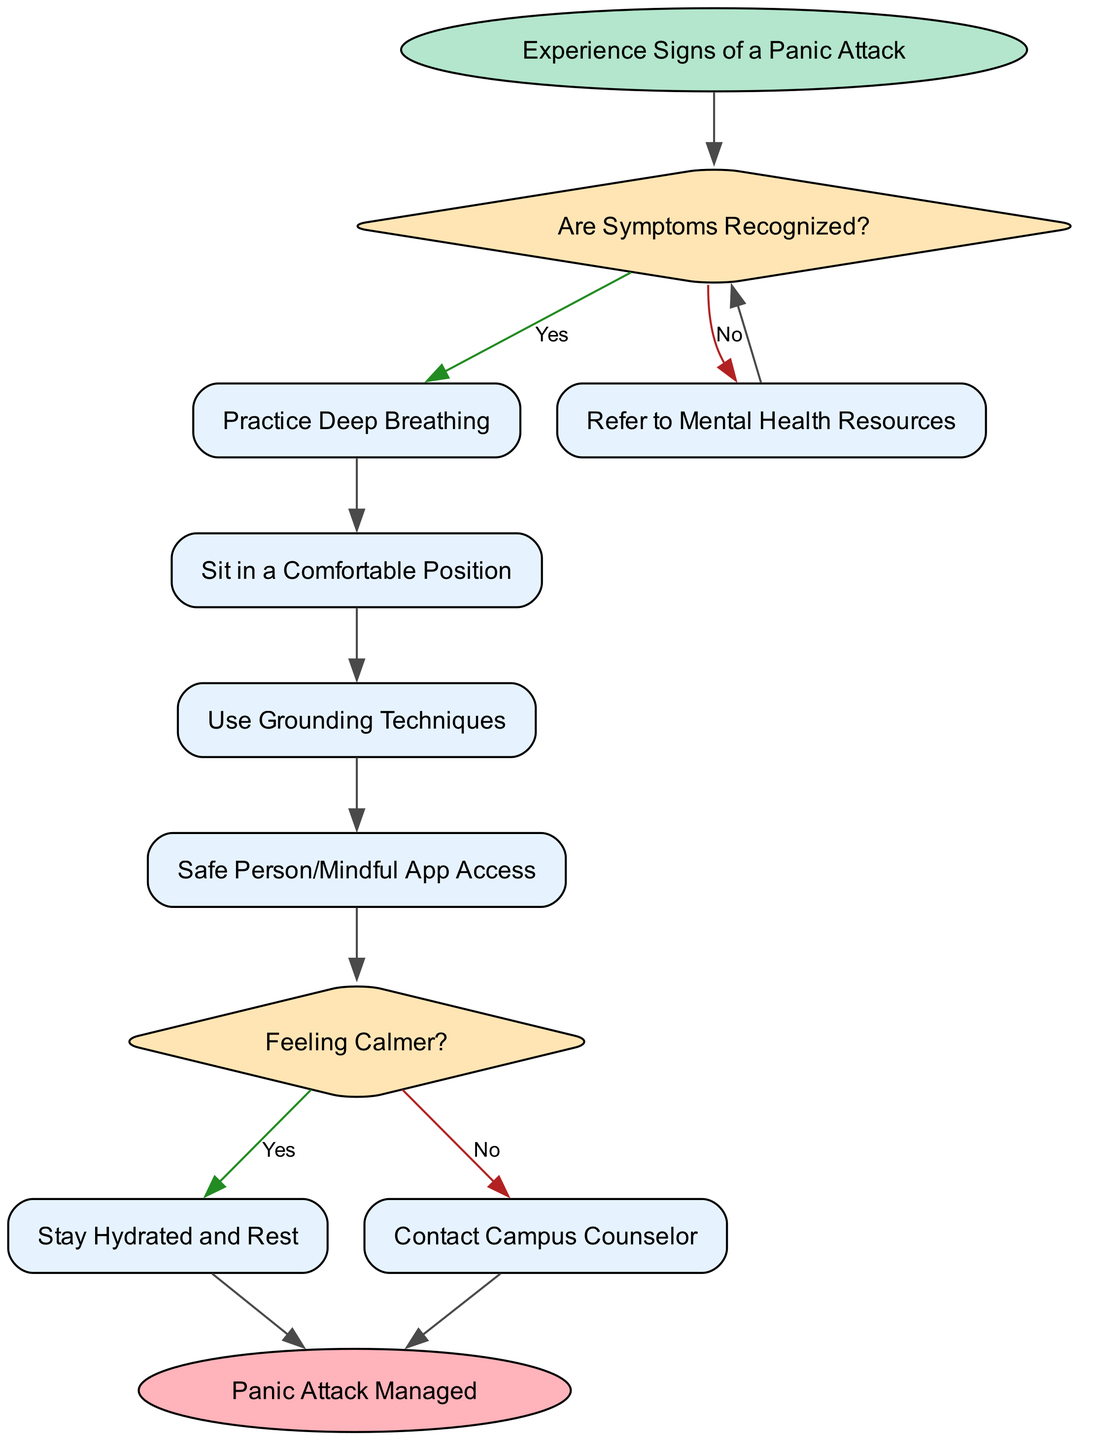What is the starting point of the flowchart? The starting point is indicated in the diagram by the first node connected to the 'start' node, which states "Experience Signs of a Panic Attack."
Answer: Experience Signs of a Panic Attack How many action nodes are there in the diagram? By counting the nodes categorized as actions, there are a total of five action nodes labeled "Practice Deep Breathing," "Sit in a Comfortable Position," "Use Grounding Techniques," "Safe Person/Mindful App Access," "Stay Hydrated and Rest," and "Contact Campus Counselor."
Answer: 6 What is the next step after recognizing symptoms of a panic attack? Following the recognition of symptoms (node 2), the next action taken is "Practice Deep Breathing" (node 3).
Answer: Practice Deep Breathing What happens if you answer "No" to the question, "Are Symptoms Recognized?" If the answer to "Are Symptoms Recognized?" is "No," the flow continues to the action "Refer to Mental Health Resources," which is represented in node 6, before returning to the start.
Answer: Refer to Mental Health Resources What condition comes after the action "Safe Person/Mindful App Access"? The next condition after "Safe Person/Mindful App Access" (node 5) is "Feeling Calmer?" which is node 7 that asks whether the individual feels calmer.
Answer: Feeling Calmer If you feel calmer after following the steps, what is the final action? If an individual feels calmer (answering "Yes" at node 7), the final action taken is "Stay Hydrated and Rest," which leads to the endpoint of the flowchart.
Answer: Stay Hydrated and Rest What is the outcome if you do not feel calmer? If the individual does not feel calmer after following the steps, the action taken is to "Contact Campus Counselor," which leads directly to the endpoint as well.
Answer: Contact Campus Counselor Which node leads to the end of the flowchart? The flowchart ends after two separate final actions; either "Stay Hydrated and Rest" or "Contact Campus Counselor," both of which point towards the end node.
Answer: end 